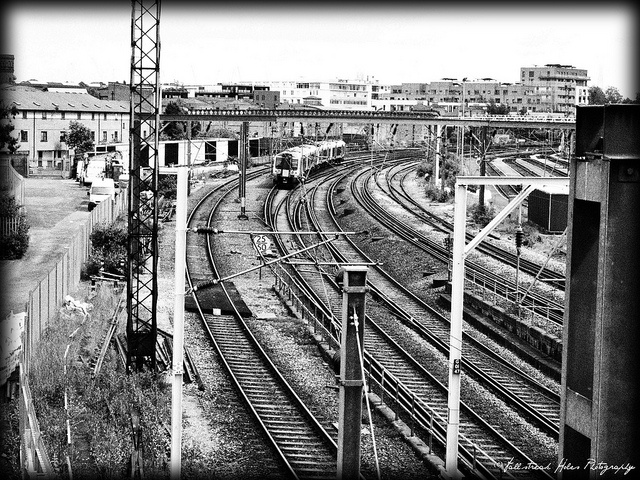Describe the objects in this image and their specific colors. I can see train in black, white, gray, and darkgray tones and truck in black, white, darkgray, and gray tones in this image. 